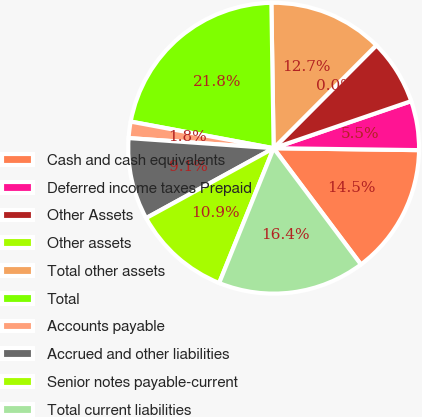<chart> <loc_0><loc_0><loc_500><loc_500><pie_chart><fcel>Cash and cash equivalents<fcel>Deferred income taxes Prepaid<fcel>Other Assets<fcel>Other assets<fcel>Total other assets<fcel>Total<fcel>Accounts payable<fcel>Accrued and other liabilities<fcel>Senior notes payable-current<fcel>Total current liabilities<nl><fcel>14.54%<fcel>5.46%<fcel>7.27%<fcel>0.0%<fcel>12.73%<fcel>21.82%<fcel>1.82%<fcel>9.09%<fcel>10.91%<fcel>16.36%<nl></chart> 